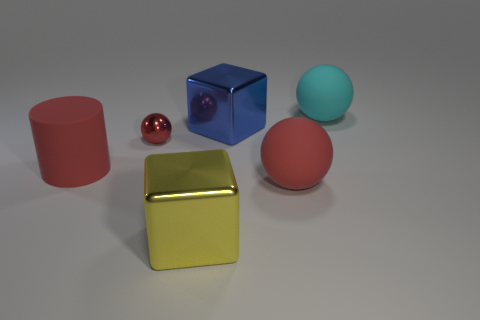What textures can you identify on the objects in the image? The objects in the image appear to have a variety of textures. The large yellow cube has a reflective, smooth texture that gives it a metallic look. The red cylinder and the blue cube also have smooth and somewhat reflective surfaces, suggesting they are made of a plastic or glossy material. The small red sphere has the highest level of reflectiveness, resembling a polished or glass-like texture, while the pink sphere has a matte, more rubbery texture by comparison. 